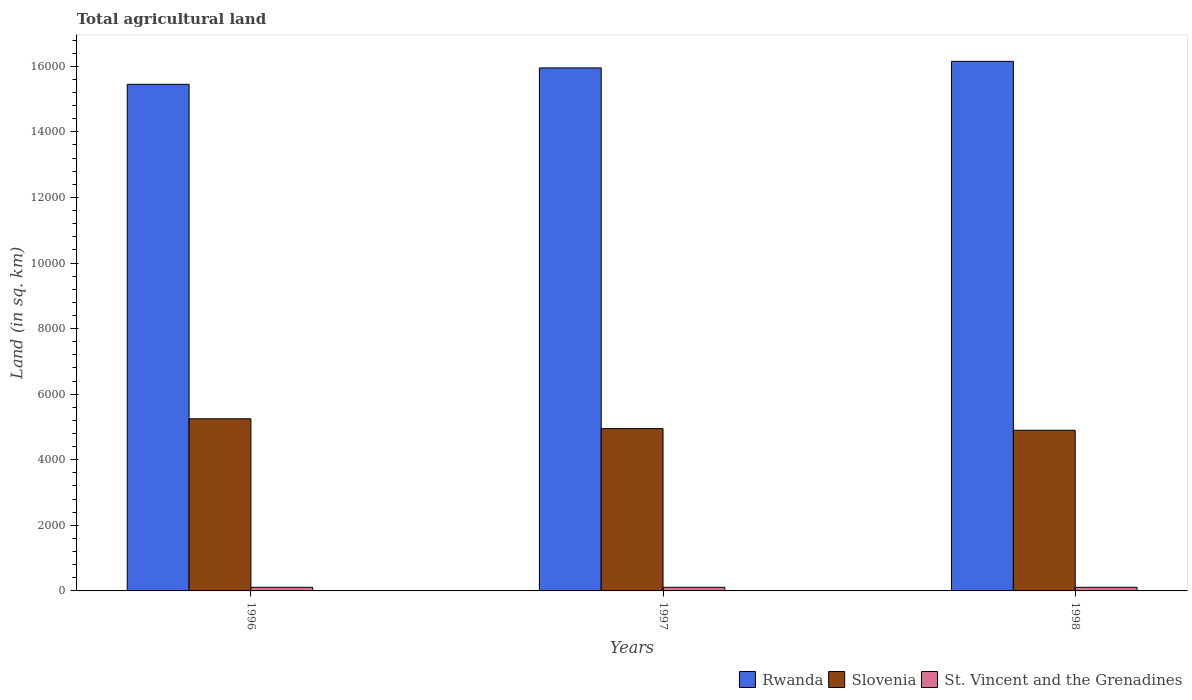How many different coloured bars are there?
Your response must be concise. 3. How many groups of bars are there?
Offer a very short reply. 3. Are the number of bars per tick equal to the number of legend labels?
Provide a succinct answer. Yes. How many bars are there on the 3rd tick from the right?
Ensure brevity in your answer.  3. What is the label of the 3rd group of bars from the left?
Offer a terse response. 1998. In how many cases, is the number of bars for a given year not equal to the number of legend labels?
Your answer should be compact. 0. What is the total agricultural land in Rwanda in 1997?
Give a very brief answer. 1.60e+04. Across all years, what is the maximum total agricultural land in Rwanda?
Provide a short and direct response. 1.62e+04. Across all years, what is the minimum total agricultural land in Rwanda?
Your answer should be very brief. 1.54e+04. In which year was the total agricultural land in Rwanda maximum?
Provide a short and direct response. 1998. In which year was the total agricultural land in Rwanda minimum?
Offer a very short reply. 1996. What is the total total agricultural land in St. Vincent and the Grenadines in the graph?
Ensure brevity in your answer.  330. What is the difference between the total agricultural land in Slovenia in 1997 and that in 1998?
Your response must be concise. 50. What is the difference between the total agricultural land in Slovenia in 1998 and the total agricultural land in Rwanda in 1996?
Your answer should be compact. -1.06e+04. What is the average total agricultural land in Slovenia per year?
Provide a succinct answer. 5033.33. In the year 1996, what is the difference between the total agricultural land in Slovenia and total agricultural land in Rwanda?
Ensure brevity in your answer.  -1.02e+04. What is the ratio of the total agricultural land in Slovenia in 1996 to that in 1997?
Your answer should be very brief. 1.06. Is the difference between the total agricultural land in Slovenia in 1996 and 1998 greater than the difference between the total agricultural land in Rwanda in 1996 and 1998?
Ensure brevity in your answer.  Yes. What is the difference between the highest and the second highest total agricultural land in St. Vincent and the Grenadines?
Ensure brevity in your answer.  0. In how many years, is the total agricultural land in Rwanda greater than the average total agricultural land in Rwanda taken over all years?
Provide a succinct answer. 2. What does the 1st bar from the left in 1997 represents?
Offer a very short reply. Rwanda. What does the 3rd bar from the right in 1998 represents?
Your answer should be compact. Rwanda. Is it the case that in every year, the sum of the total agricultural land in St. Vincent and the Grenadines and total agricultural land in Slovenia is greater than the total agricultural land in Rwanda?
Offer a terse response. No. How many bars are there?
Provide a short and direct response. 9. How many years are there in the graph?
Offer a terse response. 3. What is the difference between two consecutive major ticks on the Y-axis?
Your answer should be very brief. 2000. Does the graph contain any zero values?
Keep it short and to the point. No. Where does the legend appear in the graph?
Ensure brevity in your answer.  Bottom right. How are the legend labels stacked?
Keep it short and to the point. Horizontal. What is the title of the graph?
Your answer should be very brief. Total agricultural land. Does "Sub-Saharan Africa (all income levels)" appear as one of the legend labels in the graph?
Give a very brief answer. No. What is the label or title of the Y-axis?
Give a very brief answer. Land (in sq. km). What is the Land (in sq. km) in Rwanda in 1996?
Provide a short and direct response. 1.54e+04. What is the Land (in sq. km) of Slovenia in 1996?
Keep it short and to the point. 5250. What is the Land (in sq. km) in St. Vincent and the Grenadines in 1996?
Ensure brevity in your answer.  110. What is the Land (in sq. km) of Rwanda in 1997?
Your answer should be compact. 1.60e+04. What is the Land (in sq. km) of Slovenia in 1997?
Your response must be concise. 4950. What is the Land (in sq. km) of St. Vincent and the Grenadines in 1997?
Offer a terse response. 110. What is the Land (in sq. km) of Rwanda in 1998?
Give a very brief answer. 1.62e+04. What is the Land (in sq. km) in Slovenia in 1998?
Give a very brief answer. 4900. What is the Land (in sq. km) in St. Vincent and the Grenadines in 1998?
Your answer should be very brief. 110. Across all years, what is the maximum Land (in sq. km) of Rwanda?
Make the answer very short. 1.62e+04. Across all years, what is the maximum Land (in sq. km) in Slovenia?
Provide a succinct answer. 5250. Across all years, what is the maximum Land (in sq. km) of St. Vincent and the Grenadines?
Provide a short and direct response. 110. Across all years, what is the minimum Land (in sq. km) of Rwanda?
Your answer should be compact. 1.54e+04. Across all years, what is the minimum Land (in sq. km) in Slovenia?
Provide a short and direct response. 4900. Across all years, what is the minimum Land (in sq. km) of St. Vincent and the Grenadines?
Make the answer very short. 110. What is the total Land (in sq. km) in Rwanda in the graph?
Your answer should be compact. 4.76e+04. What is the total Land (in sq. km) of Slovenia in the graph?
Your answer should be very brief. 1.51e+04. What is the total Land (in sq. km) in St. Vincent and the Grenadines in the graph?
Your answer should be very brief. 330. What is the difference between the Land (in sq. km) in Rwanda in 1996 and that in 1997?
Offer a very short reply. -500. What is the difference between the Land (in sq. km) of Slovenia in 1996 and that in 1997?
Offer a terse response. 300. What is the difference between the Land (in sq. km) in St. Vincent and the Grenadines in 1996 and that in 1997?
Offer a very short reply. 0. What is the difference between the Land (in sq. km) in Rwanda in 1996 and that in 1998?
Your answer should be very brief. -700. What is the difference between the Land (in sq. km) in Slovenia in 1996 and that in 1998?
Provide a short and direct response. 350. What is the difference between the Land (in sq. km) of Rwanda in 1997 and that in 1998?
Make the answer very short. -200. What is the difference between the Land (in sq. km) of St. Vincent and the Grenadines in 1997 and that in 1998?
Offer a very short reply. 0. What is the difference between the Land (in sq. km) in Rwanda in 1996 and the Land (in sq. km) in Slovenia in 1997?
Ensure brevity in your answer.  1.05e+04. What is the difference between the Land (in sq. km) of Rwanda in 1996 and the Land (in sq. km) of St. Vincent and the Grenadines in 1997?
Provide a succinct answer. 1.53e+04. What is the difference between the Land (in sq. km) of Slovenia in 1996 and the Land (in sq. km) of St. Vincent and the Grenadines in 1997?
Ensure brevity in your answer.  5140. What is the difference between the Land (in sq. km) of Rwanda in 1996 and the Land (in sq. km) of Slovenia in 1998?
Provide a short and direct response. 1.06e+04. What is the difference between the Land (in sq. km) in Rwanda in 1996 and the Land (in sq. km) in St. Vincent and the Grenadines in 1998?
Your answer should be compact. 1.53e+04. What is the difference between the Land (in sq. km) in Slovenia in 1996 and the Land (in sq. km) in St. Vincent and the Grenadines in 1998?
Your answer should be compact. 5140. What is the difference between the Land (in sq. km) of Rwanda in 1997 and the Land (in sq. km) of Slovenia in 1998?
Provide a short and direct response. 1.10e+04. What is the difference between the Land (in sq. km) in Rwanda in 1997 and the Land (in sq. km) in St. Vincent and the Grenadines in 1998?
Give a very brief answer. 1.58e+04. What is the difference between the Land (in sq. km) of Slovenia in 1997 and the Land (in sq. km) of St. Vincent and the Grenadines in 1998?
Make the answer very short. 4840. What is the average Land (in sq. km) of Rwanda per year?
Provide a succinct answer. 1.58e+04. What is the average Land (in sq. km) of Slovenia per year?
Make the answer very short. 5033.33. What is the average Land (in sq. km) of St. Vincent and the Grenadines per year?
Your response must be concise. 110. In the year 1996, what is the difference between the Land (in sq. km) in Rwanda and Land (in sq. km) in Slovenia?
Keep it short and to the point. 1.02e+04. In the year 1996, what is the difference between the Land (in sq. km) in Rwanda and Land (in sq. km) in St. Vincent and the Grenadines?
Offer a terse response. 1.53e+04. In the year 1996, what is the difference between the Land (in sq. km) of Slovenia and Land (in sq. km) of St. Vincent and the Grenadines?
Provide a short and direct response. 5140. In the year 1997, what is the difference between the Land (in sq. km) of Rwanda and Land (in sq. km) of Slovenia?
Provide a succinct answer. 1.10e+04. In the year 1997, what is the difference between the Land (in sq. km) in Rwanda and Land (in sq. km) in St. Vincent and the Grenadines?
Offer a very short reply. 1.58e+04. In the year 1997, what is the difference between the Land (in sq. km) of Slovenia and Land (in sq. km) of St. Vincent and the Grenadines?
Your answer should be very brief. 4840. In the year 1998, what is the difference between the Land (in sq. km) of Rwanda and Land (in sq. km) of Slovenia?
Make the answer very short. 1.12e+04. In the year 1998, what is the difference between the Land (in sq. km) in Rwanda and Land (in sq. km) in St. Vincent and the Grenadines?
Your response must be concise. 1.60e+04. In the year 1998, what is the difference between the Land (in sq. km) of Slovenia and Land (in sq. km) of St. Vincent and the Grenadines?
Your response must be concise. 4790. What is the ratio of the Land (in sq. km) of Rwanda in 1996 to that in 1997?
Give a very brief answer. 0.97. What is the ratio of the Land (in sq. km) of Slovenia in 1996 to that in 1997?
Keep it short and to the point. 1.06. What is the ratio of the Land (in sq. km) of St. Vincent and the Grenadines in 1996 to that in 1997?
Offer a terse response. 1. What is the ratio of the Land (in sq. km) of Rwanda in 1996 to that in 1998?
Give a very brief answer. 0.96. What is the ratio of the Land (in sq. km) of Slovenia in 1996 to that in 1998?
Your response must be concise. 1.07. What is the ratio of the Land (in sq. km) of Rwanda in 1997 to that in 1998?
Offer a terse response. 0.99. What is the ratio of the Land (in sq. km) in Slovenia in 1997 to that in 1998?
Your answer should be compact. 1.01. What is the ratio of the Land (in sq. km) of St. Vincent and the Grenadines in 1997 to that in 1998?
Offer a very short reply. 1. What is the difference between the highest and the second highest Land (in sq. km) in Slovenia?
Ensure brevity in your answer.  300. What is the difference between the highest and the lowest Land (in sq. km) in Rwanda?
Provide a succinct answer. 700. What is the difference between the highest and the lowest Land (in sq. km) in Slovenia?
Your answer should be very brief. 350. 